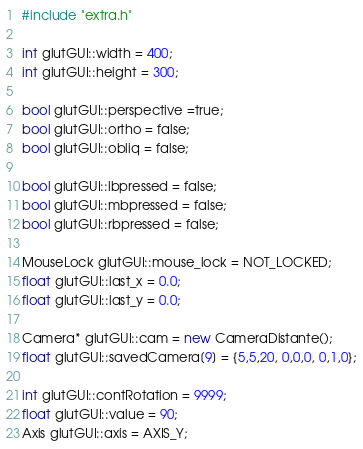Convert code to text. <code><loc_0><loc_0><loc_500><loc_500><_C++_>#include "extra.h"

int glutGUI::width = 400;
int glutGUI::height = 300;

bool glutGUI::perspective =true;
bool glutGUI::ortho = false;
bool glutGUI::obliq = false;

bool glutGUI::lbpressed = false;
bool glutGUI::mbpressed = false;
bool glutGUI::rbpressed = false;

MouseLock glutGUI::mouse_lock = NOT_LOCKED;
float glutGUI::last_x = 0.0;
float glutGUI::last_y = 0.0;

Camera* glutGUI::cam = new CameraDistante();
float glutGUI::savedCamera[9] = {5,5,20, 0,0,0, 0,1,0};

int glutGUI::contRotation = 9999;
float glutGUI::value = 90;
Axis glutGUI::axis = AXIS_Y;</code> 